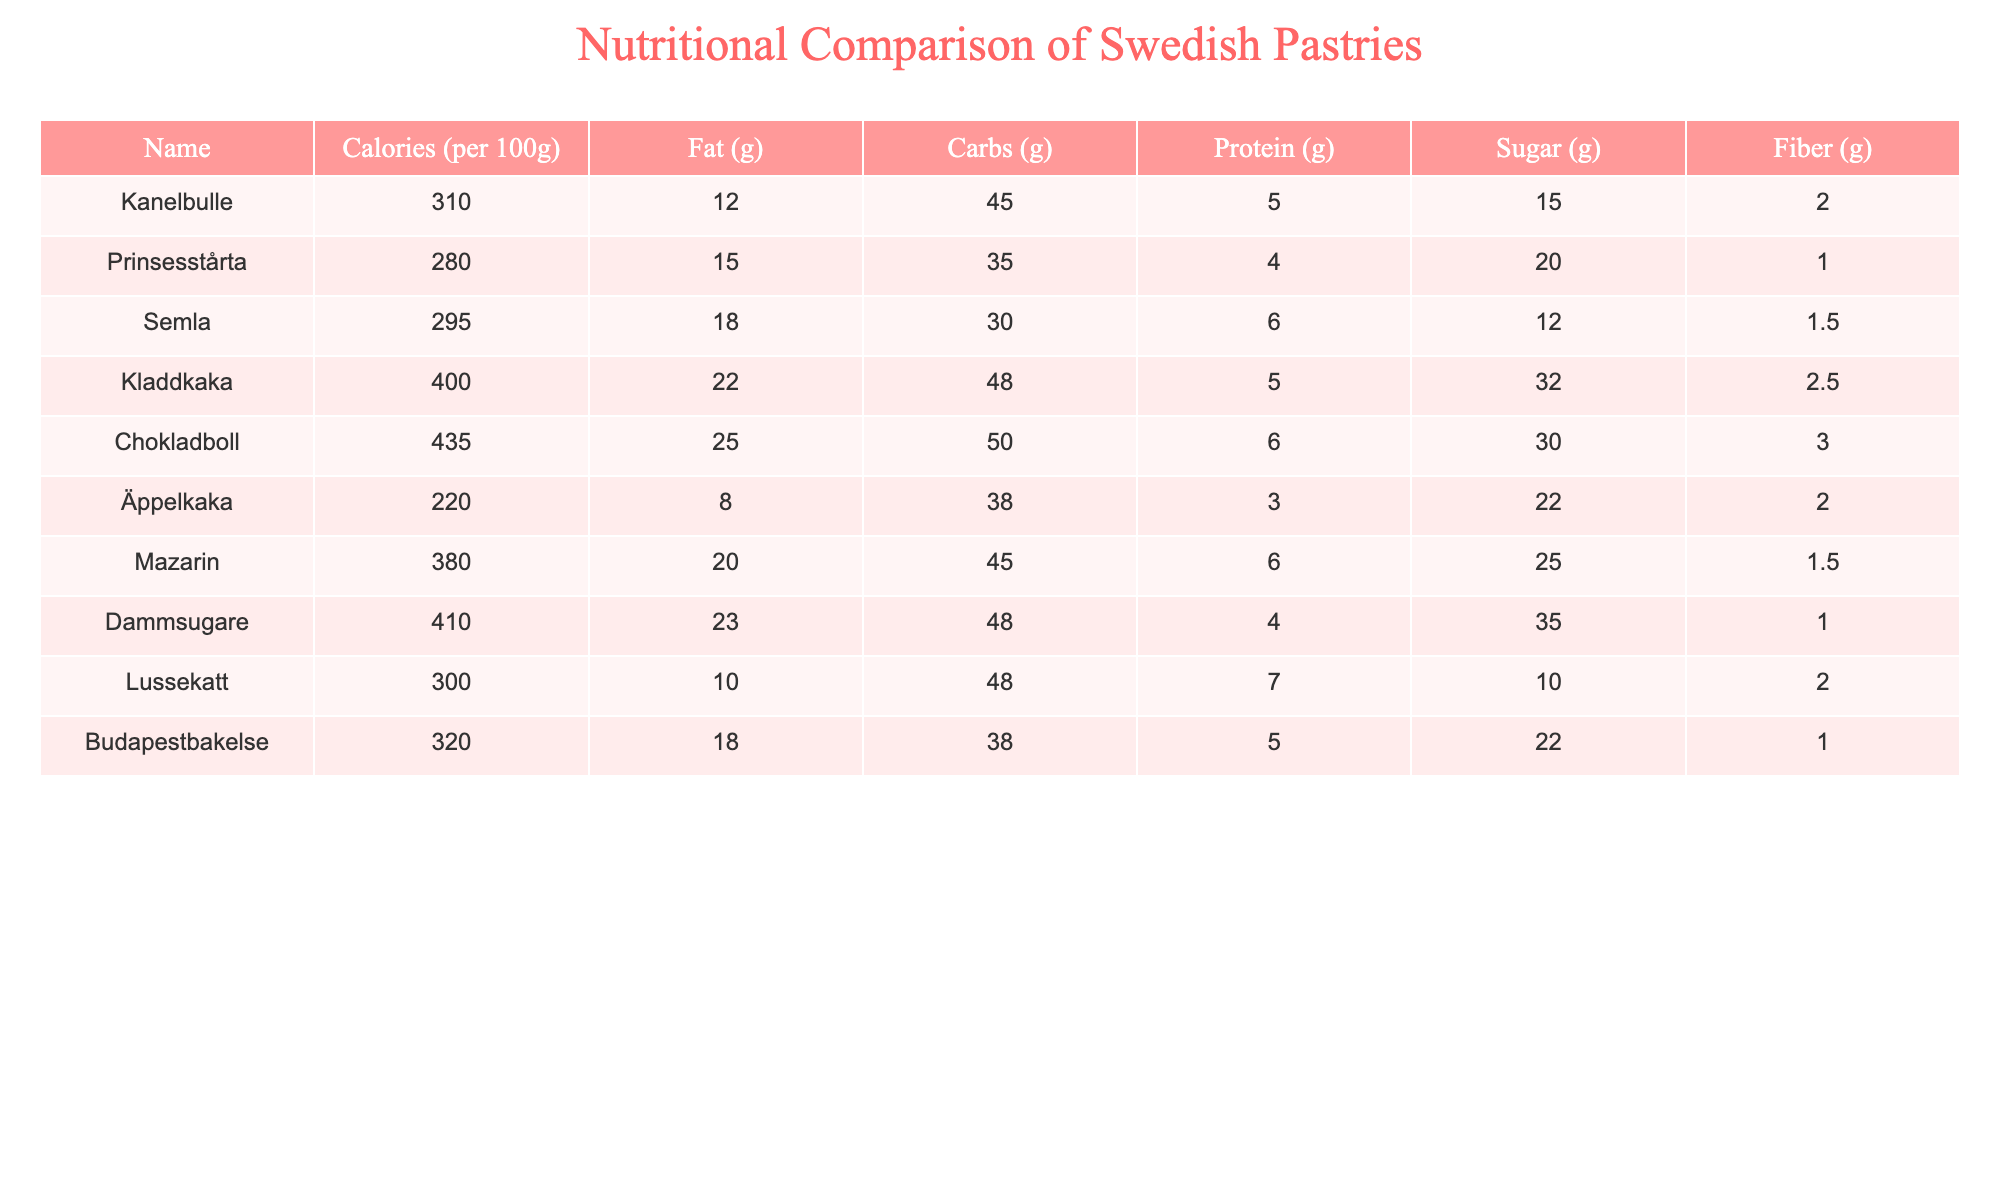What is the calorie content of Kanelbulle? Looking at the table, Kanelbulle has a calorie content listed as 310 calories per 100g.
Answer: 310 calories Which pastry has the highest sugar content? By examining the sugar column, Chokladboll has the highest sugar content at 30g per 100g.
Answer: Chokladboll What is the total fat content of Semla and Mazarin combined? Add the fat content of Semla (18g) and Mazarin (20g): 18 + 20 = 38g.
Answer: 38g Is there a pastry that contains more than 25g of fat? Checking the fat column, Chokladboll (25g) and Dammsugare (23g) are close, but no pastry exceeds 25g.
Answer: No What is the average carbohydrate content of all pastries listed? To find the average, sum all carbohydrate contents: 45 + 35 + 30 + 48 + 50 + 38 + 45 + 48 + 48 + 38 = 415g. Then divide by 10 (the number of pastries): 415 / 10 = 41.5g.
Answer: 41.5g Which pastry has the lowest fiber content? By reviewing the fiber column, Prinsesstårta shows the lowest fiber amount of 1g per 100g.
Answer: Prinsesstårta How many pastries contain more than 300 calories? Examining the calorie column, Kanelbulle (310), Kladdkaka (400), Chokladboll (435), and Dammsugare (410) are over 300 calories, totaling 4 pastries.
Answer: 4 pastries What is the difference in protein content between Äppelkaka and Lussekatt? Äppelkaka has 3g and Lussekatt has 7g of protein. The difference is 7 - 3 = 4g.
Answer: 4g Is Mazarin higher in calories than Prinsesstårta? Comparing calorie counts, Mazarin has 380 calories and Prinsesstårta has 280 calories, so Mazarin is indeed higher.
Answer: Yes What is the total sugar content of all the pastries listed? Sum the sugar values: 15 + 20 + 12 + 32 + 30 + 22 + 25 + 35 + 10 + 22 =  220g.
Answer: 220g 